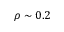<formula> <loc_0><loc_0><loc_500><loc_500>\rho \sim 0 . 2</formula> 